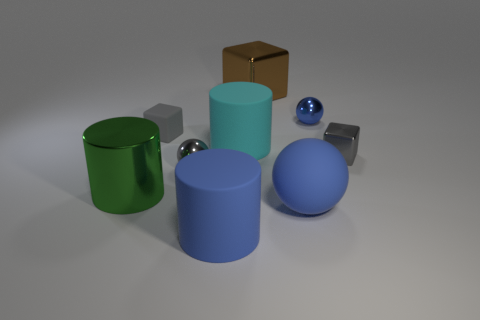Which object in the image appears to have the smoothest surface? The silver spheres seem to have the smoothest surfaces, given their reflective and unblemished appearance. 